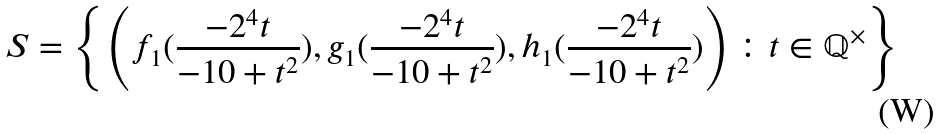<formula> <loc_0><loc_0><loc_500><loc_500>S = \left \{ \left ( f _ { 1 } ( \frac { - 2 ^ { 4 } t } { - 1 0 + t ^ { 2 } } ) , g _ { 1 } ( \frac { - 2 ^ { 4 } t } { - 1 0 + t ^ { 2 } } ) , h _ { 1 } ( \frac { - 2 ^ { 4 } t } { - 1 0 + t ^ { 2 } } ) \right ) \colon t \in \mathbb { Q } ^ { \times } \right \}</formula> 